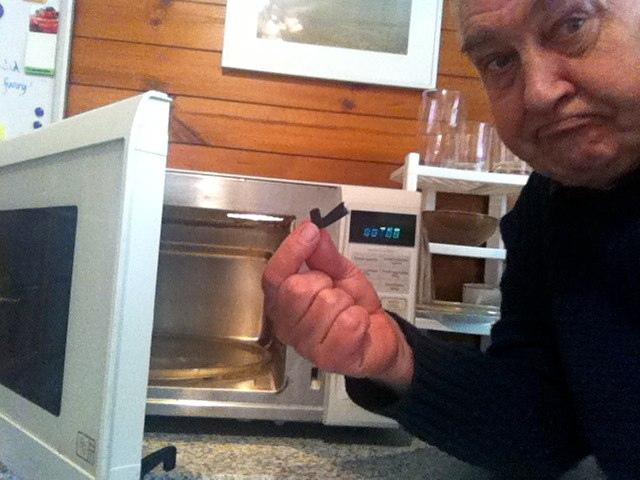What does the man hold? plastic 